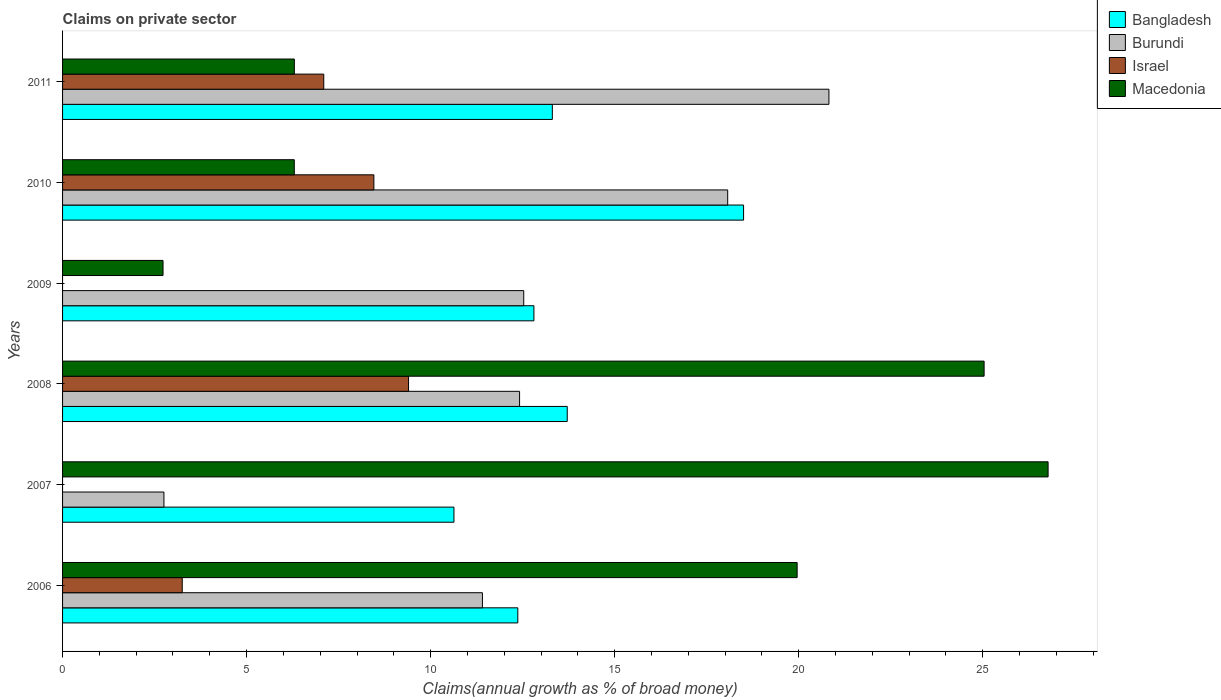Are the number of bars on each tick of the Y-axis equal?
Make the answer very short. No. How many bars are there on the 5th tick from the bottom?
Keep it short and to the point. 4. What is the percentage of broad money claimed on private sector in Bangladesh in 2006?
Give a very brief answer. 12.37. Across all years, what is the maximum percentage of broad money claimed on private sector in Bangladesh?
Provide a succinct answer. 18.5. Across all years, what is the minimum percentage of broad money claimed on private sector in Burundi?
Ensure brevity in your answer.  2.75. What is the total percentage of broad money claimed on private sector in Israel in the graph?
Offer a very short reply. 28.21. What is the difference between the percentage of broad money claimed on private sector in Israel in 2008 and that in 2011?
Your answer should be compact. 2.3. What is the difference between the percentage of broad money claimed on private sector in Bangladesh in 2006 and the percentage of broad money claimed on private sector in Macedonia in 2009?
Keep it short and to the point. 9.64. What is the average percentage of broad money claimed on private sector in Bangladesh per year?
Keep it short and to the point. 13.56. In the year 2007, what is the difference between the percentage of broad money claimed on private sector in Macedonia and percentage of broad money claimed on private sector in Bangladesh?
Offer a very short reply. 16.14. In how many years, is the percentage of broad money claimed on private sector in Burundi greater than 13 %?
Ensure brevity in your answer.  2. What is the ratio of the percentage of broad money claimed on private sector in Macedonia in 2007 to that in 2011?
Ensure brevity in your answer.  4.25. Is the percentage of broad money claimed on private sector in Macedonia in 2006 less than that in 2007?
Offer a very short reply. Yes. What is the difference between the highest and the second highest percentage of broad money claimed on private sector in Israel?
Ensure brevity in your answer.  0.94. What is the difference between the highest and the lowest percentage of broad money claimed on private sector in Bangladesh?
Ensure brevity in your answer.  7.87. Is it the case that in every year, the sum of the percentage of broad money claimed on private sector in Israel and percentage of broad money claimed on private sector in Macedonia is greater than the percentage of broad money claimed on private sector in Bangladesh?
Provide a short and direct response. No. How many bars are there?
Your response must be concise. 22. How many years are there in the graph?
Give a very brief answer. 6. Does the graph contain any zero values?
Your answer should be very brief. Yes. How many legend labels are there?
Your response must be concise. 4. How are the legend labels stacked?
Make the answer very short. Vertical. What is the title of the graph?
Your answer should be very brief. Claims on private sector. Does "Kazakhstan" appear as one of the legend labels in the graph?
Your answer should be very brief. No. What is the label or title of the X-axis?
Your response must be concise. Claims(annual growth as % of broad money). What is the label or title of the Y-axis?
Provide a short and direct response. Years. What is the Claims(annual growth as % of broad money) in Bangladesh in 2006?
Give a very brief answer. 12.37. What is the Claims(annual growth as % of broad money) in Burundi in 2006?
Your response must be concise. 11.41. What is the Claims(annual growth as % of broad money) in Israel in 2006?
Keep it short and to the point. 3.25. What is the Claims(annual growth as % of broad money) in Macedonia in 2006?
Your response must be concise. 19.96. What is the Claims(annual growth as % of broad money) in Bangladesh in 2007?
Offer a very short reply. 10.63. What is the Claims(annual growth as % of broad money) in Burundi in 2007?
Your answer should be very brief. 2.75. What is the Claims(annual growth as % of broad money) in Macedonia in 2007?
Offer a very short reply. 26.78. What is the Claims(annual growth as % of broad money) of Bangladesh in 2008?
Your response must be concise. 13.71. What is the Claims(annual growth as % of broad money) in Burundi in 2008?
Your answer should be compact. 12.42. What is the Claims(annual growth as % of broad money) of Israel in 2008?
Provide a succinct answer. 9.4. What is the Claims(annual growth as % of broad money) in Macedonia in 2008?
Offer a very short reply. 25.04. What is the Claims(annual growth as % of broad money) of Bangladesh in 2009?
Your answer should be compact. 12.81. What is the Claims(annual growth as % of broad money) in Burundi in 2009?
Make the answer very short. 12.53. What is the Claims(annual growth as % of broad money) of Israel in 2009?
Keep it short and to the point. 0. What is the Claims(annual growth as % of broad money) in Macedonia in 2009?
Give a very brief answer. 2.73. What is the Claims(annual growth as % of broad money) in Bangladesh in 2010?
Ensure brevity in your answer.  18.5. What is the Claims(annual growth as % of broad money) of Burundi in 2010?
Your answer should be compact. 18.07. What is the Claims(annual growth as % of broad money) in Israel in 2010?
Your answer should be compact. 8.46. What is the Claims(annual growth as % of broad money) of Macedonia in 2010?
Your response must be concise. 6.3. What is the Claims(annual growth as % of broad money) in Bangladesh in 2011?
Give a very brief answer. 13.31. What is the Claims(annual growth as % of broad money) of Burundi in 2011?
Provide a short and direct response. 20.82. What is the Claims(annual growth as % of broad money) of Israel in 2011?
Provide a short and direct response. 7.1. What is the Claims(annual growth as % of broad money) of Macedonia in 2011?
Your response must be concise. 6.3. Across all years, what is the maximum Claims(annual growth as % of broad money) in Bangladesh?
Make the answer very short. 18.5. Across all years, what is the maximum Claims(annual growth as % of broad money) in Burundi?
Your answer should be very brief. 20.82. Across all years, what is the maximum Claims(annual growth as % of broad money) in Israel?
Make the answer very short. 9.4. Across all years, what is the maximum Claims(annual growth as % of broad money) in Macedonia?
Provide a succinct answer. 26.78. Across all years, what is the minimum Claims(annual growth as % of broad money) of Bangladesh?
Ensure brevity in your answer.  10.63. Across all years, what is the minimum Claims(annual growth as % of broad money) of Burundi?
Your answer should be compact. 2.75. Across all years, what is the minimum Claims(annual growth as % of broad money) of Macedonia?
Offer a terse response. 2.73. What is the total Claims(annual growth as % of broad money) of Bangladesh in the graph?
Keep it short and to the point. 81.34. What is the total Claims(annual growth as % of broad money) of Burundi in the graph?
Offer a terse response. 78.01. What is the total Claims(annual growth as % of broad money) in Israel in the graph?
Your response must be concise. 28.21. What is the total Claims(annual growth as % of broad money) of Macedonia in the graph?
Your response must be concise. 87.1. What is the difference between the Claims(annual growth as % of broad money) in Bangladesh in 2006 and that in 2007?
Offer a terse response. 1.74. What is the difference between the Claims(annual growth as % of broad money) of Burundi in 2006 and that in 2007?
Offer a very short reply. 8.65. What is the difference between the Claims(annual growth as % of broad money) in Macedonia in 2006 and that in 2007?
Provide a short and direct response. -6.82. What is the difference between the Claims(annual growth as % of broad money) of Bangladesh in 2006 and that in 2008?
Give a very brief answer. -1.34. What is the difference between the Claims(annual growth as % of broad money) in Burundi in 2006 and that in 2008?
Your answer should be very brief. -1.01. What is the difference between the Claims(annual growth as % of broad money) in Israel in 2006 and that in 2008?
Offer a terse response. -6.15. What is the difference between the Claims(annual growth as % of broad money) of Macedonia in 2006 and that in 2008?
Your response must be concise. -5.08. What is the difference between the Claims(annual growth as % of broad money) of Bangladesh in 2006 and that in 2009?
Your answer should be very brief. -0.44. What is the difference between the Claims(annual growth as % of broad money) in Burundi in 2006 and that in 2009?
Provide a short and direct response. -1.12. What is the difference between the Claims(annual growth as % of broad money) in Macedonia in 2006 and that in 2009?
Ensure brevity in your answer.  17.23. What is the difference between the Claims(annual growth as % of broad money) of Bangladesh in 2006 and that in 2010?
Keep it short and to the point. -6.13. What is the difference between the Claims(annual growth as % of broad money) of Burundi in 2006 and that in 2010?
Offer a terse response. -6.66. What is the difference between the Claims(annual growth as % of broad money) in Israel in 2006 and that in 2010?
Offer a terse response. -5.21. What is the difference between the Claims(annual growth as % of broad money) of Macedonia in 2006 and that in 2010?
Offer a terse response. 13.66. What is the difference between the Claims(annual growth as % of broad money) in Bangladesh in 2006 and that in 2011?
Offer a terse response. -0.94. What is the difference between the Claims(annual growth as % of broad money) in Burundi in 2006 and that in 2011?
Ensure brevity in your answer.  -9.41. What is the difference between the Claims(annual growth as % of broad money) of Israel in 2006 and that in 2011?
Provide a short and direct response. -3.85. What is the difference between the Claims(annual growth as % of broad money) of Macedonia in 2006 and that in 2011?
Provide a succinct answer. 13.66. What is the difference between the Claims(annual growth as % of broad money) in Bangladesh in 2007 and that in 2008?
Your answer should be very brief. -3.08. What is the difference between the Claims(annual growth as % of broad money) of Burundi in 2007 and that in 2008?
Your response must be concise. -9.66. What is the difference between the Claims(annual growth as % of broad money) of Macedonia in 2007 and that in 2008?
Give a very brief answer. 1.74. What is the difference between the Claims(annual growth as % of broad money) in Bangladesh in 2007 and that in 2009?
Your response must be concise. -2.17. What is the difference between the Claims(annual growth as % of broad money) of Burundi in 2007 and that in 2009?
Give a very brief answer. -9.78. What is the difference between the Claims(annual growth as % of broad money) of Macedonia in 2007 and that in 2009?
Your response must be concise. 24.05. What is the difference between the Claims(annual growth as % of broad money) in Bangladesh in 2007 and that in 2010?
Offer a very short reply. -7.87. What is the difference between the Claims(annual growth as % of broad money) in Burundi in 2007 and that in 2010?
Provide a short and direct response. -15.32. What is the difference between the Claims(annual growth as % of broad money) of Macedonia in 2007 and that in 2010?
Provide a succinct answer. 20.48. What is the difference between the Claims(annual growth as % of broad money) in Bangladesh in 2007 and that in 2011?
Ensure brevity in your answer.  -2.67. What is the difference between the Claims(annual growth as % of broad money) in Burundi in 2007 and that in 2011?
Offer a very short reply. -18.07. What is the difference between the Claims(annual growth as % of broad money) in Macedonia in 2007 and that in 2011?
Your answer should be compact. 20.48. What is the difference between the Claims(annual growth as % of broad money) of Bangladesh in 2008 and that in 2009?
Your response must be concise. 0.91. What is the difference between the Claims(annual growth as % of broad money) in Burundi in 2008 and that in 2009?
Provide a short and direct response. -0.11. What is the difference between the Claims(annual growth as % of broad money) in Macedonia in 2008 and that in 2009?
Keep it short and to the point. 22.31. What is the difference between the Claims(annual growth as % of broad money) in Bangladesh in 2008 and that in 2010?
Offer a terse response. -4.79. What is the difference between the Claims(annual growth as % of broad money) in Burundi in 2008 and that in 2010?
Provide a succinct answer. -5.65. What is the difference between the Claims(annual growth as % of broad money) of Israel in 2008 and that in 2010?
Your response must be concise. 0.94. What is the difference between the Claims(annual growth as % of broad money) in Macedonia in 2008 and that in 2010?
Your answer should be very brief. 18.74. What is the difference between the Claims(annual growth as % of broad money) of Bangladesh in 2008 and that in 2011?
Provide a short and direct response. 0.41. What is the difference between the Claims(annual growth as % of broad money) in Burundi in 2008 and that in 2011?
Keep it short and to the point. -8.41. What is the difference between the Claims(annual growth as % of broad money) in Israel in 2008 and that in 2011?
Your response must be concise. 2.3. What is the difference between the Claims(annual growth as % of broad money) in Macedonia in 2008 and that in 2011?
Your answer should be compact. 18.74. What is the difference between the Claims(annual growth as % of broad money) of Bangladesh in 2009 and that in 2010?
Make the answer very short. -5.7. What is the difference between the Claims(annual growth as % of broad money) of Burundi in 2009 and that in 2010?
Make the answer very short. -5.54. What is the difference between the Claims(annual growth as % of broad money) of Macedonia in 2009 and that in 2010?
Offer a terse response. -3.57. What is the difference between the Claims(annual growth as % of broad money) in Bangladesh in 2009 and that in 2011?
Your answer should be very brief. -0.5. What is the difference between the Claims(annual growth as % of broad money) in Burundi in 2009 and that in 2011?
Provide a succinct answer. -8.29. What is the difference between the Claims(annual growth as % of broad money) of Macedonia in 2009 and that in 2011?
Your answer should be compact. -3.57. What is the difference between the Claims(annual growth as % of broad money) of Bangladesh in 2010 and that in 2011?
Ensure brevity in your answer.  5.2. What is the difference between the Claims(annual growth as % of broad money) in Burundi in 2010 and that in 2011?
Make the answer very short. -2.75. What is the difference between the Claims(annual growth as % of broad money) in Israel in 2010 and that in 2011?
Provide a short and direct response. 1.36. What is the difference between the Claims(annual growth as % of broad money) of Macedonia in 2010 and that in 2011?
Your answer should be compact. -0. What is the difference between the Claims(annual growth as % of broad money) in Bangladesh in 2006 and the Claims(annual growth as % of broad money) in Burundi in 2007?
Make the answer very short. 9.62. What is the difference between the Claims(annual growth as % of broad money) in Bangladesh in 2006 and the Claims(annual growth as % of broad money) in Macedonia in 2007?
Ensure brevity in your answer.  -14.41. What is the difference between the Claims(annual growth as % of broad money) of Burundi in 2006 and the Claims(annual growth as % of broad money) of Macedonia in 2007?
Your answer should be compact. -15.37. What is the difference between the Claims(annual growth as % of broad money) of Israel in 2006 and the Claims(annual growth as % of broad money) of Macedonia in 2007?
Offer a very short reply. -23.53. What is the difference between the Claims(annual growth as % of broad money) of Bangladesh in 2006 and the Claims(annual growth as % of broad money) of Burundi in 2008?
Provide a succinct answer. -0.05. What is the difference between the Claims(annual growth as % of broad money) of Bangladesh in 2006 and the Claims(annual growth as % of broad money) of Israel in 2008?
Ensure brevity in your answer.  2.97. What is the difference between the Claims(annual growth as % of broad money) of Bangladesh in 2006 and the Claims(annual growth as % of broad money) of Macedonia in 2008?
Your answer should be very brief. -12.67. What is the difference between the Claims(annual growth as % of broad money) in Burundi in 2006 and the Claims(annual growth as % of broad money) in Israel in 2008?
Your answer should be very brief. 2.01. What is the difference between the Claims(annual growth as % of broad money) in Burundi in 2006 and the Claims(annual growth as % of broad money) in Macedonia in 2008?
Offer a terse response. -13.63. What is the difference between the Claims(annual growth as % of broad money) in Israel in 2006 and the Claims(annual growth as % of broad money) in Macedonia in 2008?
Give a very brief answer. -21.79. What is the difference between the Claims(annual growth as % of broad money) of Bangladesh in 2006 and the Claims(annual growth as % of broad money) of Burundi in 2009?
Offer a terse response. -0.16. What is the difference between the Claims(annual growth as % of broad money) of Bangladesh in 2006 and the Claims(annual growth as % of broad money) of Macedonia in 2009?
Your answer should be very brief. 9.64. What is the difference between the Claims(annual growth as % of broad money) in Burundi in 2006 and the Claims(annual growth as % of broad money) in Macedonia in 2009?
Make the answer very short. 8.68. What is the difference between the Claims(annual growth as % of broad money) in Israel in 2006 and the Claims(annual growth as % of broad money) in Macedonia in 2009?
Offer a terse response. 0.52. What is the difference between the Claims(annual growth as % of broad money) in Bangladesh in 2006 and the Claims(annual growth as % of broad money) in Burundi in 2010?
Provide a short and direct response. -5.7. What is the difference between the Claims(annual growth as % of broad money) of Bangladesh in 2006 and the Claims(annual growth as % of broad money) of Israel in 2010?
Offer a terse response. 3.91. What is the difference between the Claims(annual growth as % of broad money) of Bangladesh in 2006 and the Claims(annual growth as % of broad money) of Macedonia in 2010?
Offer a very short reply. 6.07. What is the difference between the Claims(annual growth as % of broad money) of Burundi in 2006 and the Claims(annual growth as % of broad money) of Israel in 2010?
Your answer should be compact. 2.95. What is the difference between the Claims(annual growth as % of broad money) in Burundi in 2006 and the Claims(annual growth as % of broad money) in Macedonia in 2010?
Make the answer very short. 5.11. What is the difference between the Claims(annual growth as % of broad money) in Israel in 2006 and the Claims(annual growth as % of broad money) in Macedonia in 2010?
Your response must be concise. -3.04. What is the difference between the Claims(annual growth as % of broad money) in Bangladesh in 2006 and the Claims(annual growth as % of broad money) in Burundi in 2011?
Offer a terse response. -8.45. What is the difference between the Claims(annual growth as % of broad money) in Bangladesh in 2006 and the Claims(annual growth as % of broad money) in Israel in 2011?
Make the answer very short. 5.27. What is the difference between the Claims(annual growth as % of broad money) of Bangladesh in 2006 and the Claims(annual growth as % of broad money) of Macedonia in 2011?
Provide a short and direct response. 6.07. What is the difference between the Claims(annual growth as % of broad money) of Burundi in 2006 and the Claims(annual growth as % of broad money) of Israel in 2011?
Offer a terse response. 4.31. What is the difference between the Claims(annual growth as % of broad money) of Burundi in 2006 and the Claims(annual growth as % of broad money) of Macedonia in 2011?
Keep it short and to the point. 5.11. What is the difference between the Claims(annual growth as % of broad money) of Israel in 2006 and the Claims(annual growth as % of broad money) of Macedonia in 2011?
Your answer should be compact. -3.05. What is the difference between the Claims(annual growth as % of broad money) in Bangladesh in 2007 and the Claims(annual growth as % of broad money) in Burundi in 2008?
Provide a short and direct response. -1.78. What is the difference between the Claims(annual growth as % of broad money) in Bangladesh in 2007 and the Claims(annual growth as % of broad money) in Israel in 2008?
Your answer should be very brief. 1.23. What is the difference between the Claims(annual growth as % of broad money) of Bangladesh in 2007 and the Claims(annual growth as % of broad money) of Macedonia in 2008?
Your answer should be compact. -14.4. What is the difference between the Claims(annual growth as % of broad money) of Burundi in 2007 and the Claims(annual growth as % of broad money) of Israel in 2008?
Offer a terse response. -6.65. What is the difference between the Claims(annual growth as % of broad money) of Burundi in 2007 and the Claims(annual growth as % of broad money) of Macedonia in 2008?
Offer a terse response. -22.28. What is the difference between the Claims(annual growth as % of broad money) of Bangladesh in 2007 and the Claims(annual growth as % of broad money) of Burundi in 2009?
Keep it short and to the point. -1.9. What is the difference between the Claims(annual growth as % of broad money) of Bangladesh in 2007 and the Claims(annual growth as % of broad money) of Macedonia in 2009?
Offer a terse response. 7.9. What is the difference between the Claims(annual growth as % of broad money) of Burundi in 2007 and the Claims(annual growth as % of broad money) of Macedonia in 2009?
Provide a short and direct response. 0.02. What is the difference between the Claims(annual growth as % of broad money) of Bangladesh in 2007 and the Claims(annual growth as % of broad money) of Burundi in 2010?
Your response must be concise. -7.44. What is the difference between the Claims(annual growth as % of broad money) in Bangladesh in 2007 and the Claims(annual growth as % of broad money) in Israel in 2010?
Provide a succinct answer. 2.18. What is the difference between the Claims(annual growth as % of broad money) in Bangladesh in 2007 and the Claims(annual growth as % of broad money) in Macedonia in 2010?
Offer a terse response. 4.34. What is the difference between the Claims(annual growth as % of broad money) in Burundi in 2007 and the Claims(annual growth as % of broad money) in Israel in 2010?
Ensure brevity in your answer.  -5.7. What is the difference between the Claims(annual growth as % of broad money) of Burundi in 2007 and the Claims(annual growth as % of broad money) of Macedonia in 2010?
Your response must be concise. -3.54. What is the difference between the Claims(annual growth as % of broad money) of Bangladesh in 2007 and the Claims(annual growth as % of broad money) of Burundi in 2011?
Give a very brief answer. -10.19. What is the difference between the Claims(annual growth as % of broad money) in Bangladesh in 2007 and the Claims(annual growth as % of broad money) in Israel in 2011?
Your answer should be compact. 3.54. What is the difference between the Claims(annual growth as % of broad money) of Bangladesh in 2007 and the Claims(annual growth as % of broad money) of Macedonia in 2011?
Provide a short and direct response. 4.34. What is the difference between the Claims(annual growth as % of broad money) of Burundi in 2007 and the Claims(annual growth as % of broad money) of Israel in 2011?
Ensure brevity in your answer.  -4.34. What is the difference between the Claims(annual growth as % of broad money) in Burundi in 2007 and the Claims(annual growth as % of broad money) in Macedonia in 2011?
Provide a succinct answer. -3.54. What is the difference between the Claims(annual growth as % of broad money) of Bangladesh in 2008 and the Claims(annual growth as % of broad money) of Burundi in 2009?
Make the answer very short. 1.18. What is the difference between the Claims(annual growth as % of broad money) of Bangladesh in 2008 and the Claims(annual growth as % of broad money) of Macedonia in 2009?
Make the answer very short. 10.98. What is the difference between the Claims(annual growth as % of broad money) in Burundi in 2008 and the Claims(annual growth as % of broad money) in Macedonia in 2009?
Make the answer very short. 9.69. What is the difference between the Claims(annual growth as % of broad money) of Israel in 2008 and the Claims(annual growth as % of broad money) of Macedonia in 2009?
Keep it short and to the point. 6.67. What is the difference between the Claims(annual growth as % of broad money) of Bangladesh in 2008 and the Claims(annual growth as % of broad money) of Burundi in 2010?
Ensure brevity in your answer.  -4.36. What is the difference between the Claims(annual growth as % of broad money) of Bangladesh in 2008 and the Claims(annual growth as % of broad money) of Israel in 2010?
Offer a terse response. 5.25. What is the difference between the Claims(annual growth as % of broad money) of Bangladesh in 2008 and the Claims(annual growth as % of broad money) of Macedonia in 2010?
Provide a succinct answer. 7.42. What is the difference between the Claims(annual growth as % of broad money) of Burundi in 2008 and the Claims(annual growth as % of broad money) of Israel in 2010?
Offer a very short reply. 3.96. What is the difference between the Claims(annual growth as % of broad money) in Burundi in 2008 and the Claims(annual growth as % of broad money) in Macedonia in 2010?
Your answer should be very brief. 6.12. What is the difference between the Claims(annual growth as % of broad money) of Israel in 2008 and the Claims(annual growth as % of broad money) of Macedonia in 2010?
Give a very brief answer. 3.1. What is the difference between the Claims(annual growth as % of broad money) of Bangladesh in 2008 and the Claims(annual growth as % of broad money) of Burundi in 2011?
Your answer should be compact. -7.11. What is the difference between the Claims(annual growth as % of broad money) in Bangladesh in 2008 and the Claims(annual growth as % of broad money) in Israel in 2011?
Your answer should be compact. 6.62. What is the difference between the Claims(annual growth as % of broad money) in Bangladesh in 2008 and the Claims(annual growth as % of broad money) in Macedonia in 2011?
Ensure brevity in your answer.  7.42. What is the difference between the Claims(annual growth as % of broad money) in Burundi in 2008 and the Claims(annual growth as % of broad money) in Israel in 2011?
Your answer should be compact. 5.32. What is the difference between the Claims(annual growth as % of broad money) in Burundi in 2008 and the Claims(annual growth as % of broad money) in Macedonia in 2011?
Make the answer very short. 6.12. What is the difference between the Claims(annual growth as % of broad money) in Israel in 2008 and the Claims(annual growth as % of broad money) in Macedonia in 2011?
Offer a terse response. 3.1. What is the difference between the Claims(annual growth as % of broad money) in Bangladesh in 2009 and the Claims(annual growth as % of broad money) in Burundi in 2010?
Your answer should be very brief. -5.26. What is the difference between the Claims(annual growth as % of broad money) in Bangladesh in 2009 and the Claims(annual growth as % of broad money) in Israel in 2010?
Keep it short and to the point. 4.35. What is the difference between the Claims(annual growth as % of broad money) in Bangladesh in 2009 and the Claims(annual growth as % of broad money) in Macedonia in 2010?
Offer a very short reply. 6.51. What is the difference between the Claims(annual growth as % of broad money) in Burundi in 2009 and the Claims(annual growth as % of broad money) in Israel in 2010?
Your answer should be compact. 4.07. What is the difference between the Claims(annual growth as % of broad money) in Burundi in 2009 and the Claims(annual growth as % of broad money) in Macedonia in 2010?
Provide a succinct answer. 6.23. What is the difference between the Claims(annual growth as % of broad money) of Bangladesh in 2009 and the Claims(annual growth as % of broad money) of Burundi in 2011?
Offer a terse response. -8.02. What is the difference between the Claims(annual growth as % of broad money) of Bangladesh in 2009 and the Claims(annual growth as % of broad money) of Israel in 2011?
Give a very brief answer. 5.71. What is the difference between the Claims(annual growth as % of broad money) of Bangladesh in 2009 and the Claims(annual growth as % of broad money) of Macedonia in 2011?
Offer a very short reply. 6.51. What is the difference between the Claims(annual growth as % of broad money) in Burundi in 2009 and the Claims(annual growth as % of broad money) in Israel in 2011?
Your answer should be very brief. 5.43. What is the difference between the Claims(annual growth as % of broad money) in Burundi in 2009 and the Claims(annual growth as % of broad money) in Macedonia in 2011?
Offer a terse response. 6.23. What is the difference between the Claims(annual growth as % of broad money) in Bangladesh in 2010 and the Claims(annual growth as % of broad money) in Burundi in 2011?
Offer a terse response. -2.32. What is the difference between the Claims(annual growth as % of broad money) in Bangladesh in 2010 and the Claims(annual growth as % of broad money) in Israel in 2011?
Keep it short and to the point. 11.41. What is the difference between the Claims(annual growth as % of broad money) of Bangladesh in 2010 and the Claims(annual growth as % of broad money) of Macedonia in 2011?
Provide a short and direct response. 12.21. What is the difference between the Claims(annual growth as % of broad money) in Burundi in 2010 and the Claims(annual growth as % of broad money) in Israel in 2011?
Make the answer very short. 10.97. What is the difference between the Claims(annual growth as % of broad money) in Burundi in 2010 and the Claims(annual growth as % of broad money) in Macedonia in 2011?
Ensure brevity in your answer.  11.77. What is the difference between the Claims(annual growth as % of broad money) in Israel in 2010 and the Claims(annual growth as % of broad money) in Macedonia in 2011?
Your response must be concise. 2.16. What is the average Claims(annual growth as % of broad money) of Bangladesh per year?
Keep it short and to the point. 13.56. What is the average Claims(annual growth as % of broad money) of Burundi per year?
Make the answer very short. 13. What is the average Claims(annual growth as % of broad money) in Israel per year?
Your answer should be very brief. 4.7. What is the average Claims(annual growth as % of broad money) of Macedonia per year?
Provide a succinct answer. 14.52. In the year 2006, what is the difference between the Claims(annual growth as % of broad money) of Bangladesh and Claims(annual growth as % of broad money) of Burundi?
Ensure brevity in your answer.  0.96. In the year 2006, what is the difference between the Claims(annual growth as % of broad money) in Bangladesh and Claims(annual growth as % of broad money) in Israel?
Ensure brevity in your answer.  9.12. In the year 2006, what is the difference between the Claims(annual growth as % of broad money) in Bangladesh and Claims(annual growth as % of broad money) in Macedonia?
Provide a succinct answer. -7.59. In the year 2006, what is the difference between the Claims(annual growth as % of broad money) of Burundi and Claims(annual growth as % of broad money) of Israel?
Ensure brevity in your answer.  8.16. In the year 2006, what is the difference between the Claims(annual growth as % of broad money) of Burundi and Claims(annual growth as % of broad money) of Macedonia?
Keep it short and to the point. -8.55. In the year 2006, what is the difference between the Claims(annual growth as % of broad money) of Israel and Claims(annual growth as % of broad money) of Macedonia?
Your response must be concise. -16.71. In the year 2007, what is the difference between the Claims(annual growth as % of broad money) of Bangladesh and Claims(annual growth as % of broad money) of Burundi?
Ensure brevity in your answer.  7.88. In the year 2007, what is the difference between the Claims(annual growth as % of broad money) in Bangladesh and Claims(annual growth as % of broad money) in Macedonia?
Ensure brevity in your answer.  -16.14. In the year 2007, what is the difference between the Claims(annual growth as % of broad money) of Burundi and Claims(annual growth as % of broad money) of Macedonia?
Provide a short and direct response. -24.02. In the year 2008, what is the difference between the Claims(annual growth as % of broad money) in Bangladesh and Claims(annual growth as % of broad money) in Burundi?
Keep it short and to the point. 1.3. In the year 2008, what is the difference between the Claims(annual growth as % of broad money) of Bangladesh and Claims(annual growth as % of broad money) of Israel?
Provide a succinct answer. 4.31. In the year 2008, what is the difference between the Claims(annual growth as % of broad money) in Bangladesh and Claims(annual growth as % of broad money) in Macedonia?
Provide a short and direct response. -11.33. In the year 2008, what is the difference between the Claims(annual growth as % of broad money) of Burundi and Claims(annual growth as % of broad money) of Israel?
Ensure brevity in your answer.  3.02. In the year 2008, what is the difference between the Claims(annual growth as % of broad money) in Burundi and Claims(annual growth as % of broad money) in Macedonia?
Give a very brief answer. -12.62. In the year 2008, what is the difference between the Claims(annual growth as % of broad money) of Israel and Claims(annual growth as % of broad money) of Macedonia?
Your answer should be compact. -15.64. In the year 2009, what is the difference between the Claims(annual growth as % of broad money) of Bangladesh and Claims(annual growth as % of broad money) of Burundi?
Provide a short and direct response. 0.28. In the year 2009, what is the difference between the Claims(annual growth as % of broad money) in Bangladesh and Claims(annual growth as % of broad money) in Macedonia?
Your answer should be compact. 10.08. In the year 2009, what is the difference between the Claims(annual growth as % of broad money) in Burundi and Claims(annual growth as % of broad money) in Macedonia?
Give a very brief answer. 9.8. In the year 2010, what is the difference between the Claims(annual growth as % of broad money) in Bangladesh and Claims(annual growth as % of broad money) in Burundi?
Keep it short and to the point. 0.43. In the year 2010, what is the difference between the Claims(annual growth as % of broad money) in Bangladesh and Claims(annual growth as % of broad money) in Israel?
Keep it short and to the point. 10.05. In the year 2010, what is the difference between the Claims(annual growth as % of broad money) in Bangladesh and Claims(annual growth as % of broad money) in Macedonia?
Offer a very short reply. 12.21. In the year 2010, what is the difference between the Claims(annual growth as % of broad money) of Burundi and Claims(annual growth as % of broad money) of Israel?
Offer a terse response. 9.61. In the year 2010, what is the difference between the Claims(annual growth as % of broad money) in Burundi and Claims(annual growth as % of broad money) in Macedonia?
Give a very brief answer. 11.78. In the year 2010, what is the difference between the Claims(annual growth as % of broad money) of Israel and Claims(annual growth as % of broad money) of Macedonia?
Your response must be concise. 2.16. In the year 2011, what is the difference between the Claims(annual growth as % of broad money) of Bangladesh and Claims(annual growth as % of broad money) of Burundi?
Your response must be concise. -7.52. In the year 2011, what is the difference between the Claims(annual growth as % of broad money) in Bangladesh and Claims(annual growth as % of broad money) in Israel?
Ensure brevity in your answer.  6.21. In the year 2011, what is the difference between the Claims(annual growth as % of broad money) of Bangladesh and Claims(annual growth as % of broad money) of Macedonia?
Provide a short and direct response. 7.01. In the year 2011, what is the difference between the Claims(annual growth as % of broad money) of Burundi and Claims(annual growth as % of broad money) of Israel?
Offer a very short reply. 13.73. In the year 2011, what is the difference between the Claims(annual growth as % of broad money) of Burundi and Claims(annual growth as % of broad money) of Macedonia?
Your answer should be very brief. 14.53. In the year 2011, what is the difference between the Claims(annual growth as % of broad money) of Israel and Claims(annual growth as % of broad money) of Macedonia?
Provide a succinct answer. 0.8. What is the ratio of the Claims(annual growth as % of broad money) in Bangladesh in 2006 to that in 2007?
Your answer should be very brief. 1.16. What is the ratio of the Claims(annual growth as % of broad money) in Burundi in 2006 to that in 2007?
Offer a terse response. 4.14. What is the ratio of the Claims(annual growth as % of broad money) in Macedonia in 2006 to that in 2007?
Provide a succinct answer. 0.75. What is the ratio of the Claims(annual growth as % of broad money) in Bangladesh in 2006 to that in 2008?
Provide a short and direct response. 0.9. What is the ratio of the Claims(annual growth as % of broad money) of Burundi in 2006 to that in 2008?
Provide a short and direct response. 0.92. What is the ratio of the Claims(annual growth as % of broad money) in Israel in 2006 to that in 2008?
Provide a short and direct response. 0.35. What is the ratio of the Claims(annual growth as % of broad money) of Macedonia in 2006 to that in 2008?
Offer a very short reply. 0.8. What is the ratio of the Claims(annual growth as % of broad money) of Bangladesh in 2006 to that in 2009?
Your answer should be compact. 0.97. What is the ratio of the Claims(annual growth as % of broad money) in Burundi in 2006 to that in 2009?
Keep it short and to the point. 0.91. What is the ratio of the Claims(annual growth as % of broad money) in Macedonia in 2006 to that in 2009?
Your answer should be compact. 7.31. What is the ratio of the Claims(annual growth as % of broad money) of Bangladesh in 2006 to that in 2010?
Offer a very short reply. 0.67. What is the ratio of the Claims(annual growth as % of broad money) of Burundi in 2006 to that in 2010?
Offer a very short reply. 0.63. What is the ratio of the Claims(annual growth as % of broad money) of Israel in 2006 to that in 2010?
Offer a very short reply. 0.38. What is the ratio of the Claims(annual growth as % of broad money) of Macedonia in 2006 to that in 2010?
Your answer should be very brief. 3.17. What is the ratio of the Claims(annual growth as % of broad money) of Bangladesh in 2006 to that in 2011?
Keep it short and to the point. 0.93. What is the ratio of the Claims(annual growth as % of broad money) of Burundi in 2006 to that in 2011?
Your answer should be very brief. 0.55. What is the ratio of the Claims(annual growth as % of broad money) of Israel in 2006 to that in 2011?
Your response must be concise. 0.46. What is the ratio of the Claims(annual growth as % of broad money) of Macedonia in 2006 to that in 2011?
Ensure brevity in your answer.  3.17. What is the ratio of the Claims(annual growth as % of broad money) in Bangladesh in 2007 to that in 2008?
Your response must be concise. 0.78. What is the ratio of the Claims(annual growth as % of broad money) of Burundi in 2007 to that in 2008?
Provide a short and direct response. 0.22. What is the ratio of the Claims(annual growth as % of broad money) of Macedonia in 2007 to that in 2008?
Your answer should be compact. 1.07. What is the ratio of the Claims(annual growth as % of broad money) of Bangladesh in 2007 to that in 2009?
Your answer should be compact. 0.83. What is the ratio of the Claims(annual growth as % of broad money) of Burundi in 2007 to that in 2009?
Give a very brief answer. 0.22. What is the ratio of the Claims(annual growth as % of broad money) of Macedonia in 2007 to that in 2009?
Provide a short and direct response. 9.81. What is the ratio of the Claims(annual growth as % of broad money) in Bangladesh in 2007 to that in 2010?
Keep it short and to the point. 0.57. What is the ratio of the Claims(annual growth as % of broad money) in Burundi in 2007 to that in 2010?
Provide a short and direct response. 0.15. What is the ratio of the Claims(annual growth as % of broad money) in Macedonia in 2007 to that in 2010?
Keep it short and to the point. 4.25. What is the ratio of the Claims(annual growth as % of broad money) of Bangladesh in 2007 to that in 2011?
Your answer should be compact. 0.8. What is the ratio of the Claims(annual growth as % of broad money) of Burundi in 2007 to that in 2011?
Provide a succinct answer. 0.13. What is the ratio of the Claims(annual growth as % of broad money) in Macedonia in 2007 to that in 2011?
Your answer should be compact. 4.25. What is the ratio of the Claims(annual growth as % of broad money) of Bangladesh in 2008 to that in 2009?
Your answer should be compact. 1.07. What is the ratio of the Claims(annual growth as % of broad money) in Macedonia in 2008 to that in 2009?
Offer a terse response. 9.17. What is the ratio of the Claims(annual growth as % of broad money) of Bangladesh in 2008 to that in 2010?
Your answer should be very brief. 0.74. What is the ratio of the Claims(annual growth as % of broad money) in Burundi in 2008 to that in 2010?
Ensure brevity in your answer.  0.69. What is the ratio of the Claims(annual growth as % of broad money) of Israel in 2008 to that in 2010?
Your response must be concise. 1.11. What is the ratio of the Claims(annual growth as % of broad money) of Macedonia in 2008 to that in 2010?
Make the answer very short. 3.98. What is the ratio of the Claims(annual growth as % of broad money) in Bangladesh in 2008 to that in 2011?
Offer a terse response. 1.03. What is the ratio of the Claims(annual growth as % of broad money) in Burundi in 2008 to that in 2011?
Make the answer very short. 0.6. What is the ratio of the Claims(annual growth as % of broad money) of Israel in 2008 to that in 2011?
Give a very brief answer. 1.32. What is the ratio of the Claims(annual growth as % of broad money) in Macedonia in 2008 to that in 2011?
Your answer should be compact. 3.98. What is the ratio of the Claims(annual growth as % of broad money) of Bangladesh in 2009 to that in 2010?
Keep it short and to the point. 0.69. What is the ratio of the Claims(annual growth as % of broad money) in Burundi in 2009 to that in 2010?
Ensure brevity in your answer.  0.69. What is the ratio of the Claims(annual growth as % of broad money) of Macedonia in 2009 to that in 2010?
Offer a terse response. 0.43. What is the ratio of the Claims(annual growth as % of broad money) in Bangladesh in 2009 to that in 2011?
Keep it short and to the point. 0.96. What is the ratio of the Claims(annual growth as % of broad money) in Burundi in 2009 to that in 2011?
Keep it short and to the point. 0.6. What is the ratio of the Claims(annual growth as % of broad money) of Macedonia in 2009 to that in 2011?
Provide a succinct answer. 0.43. What is the ratio of the Claims(annual growth as % of broad money) of Bangladesh in 2010 to that in 2011?
Give a very brief answer. 1.39. What is the ratio of the Claims(annual growth as % of broad money) in Burundi in 2010 to that in 2011?
Give a very brief answer. 0.87. What is the ratio of the Claims(annual growth as % of broad money) of Israel in 2010 to that in 2011?
Offer a very short reply. 1.19. What is the difference between the highest and the second highest Claims(annual growth as % of broad money) in Bangladesh?
Provide a succinct answer. 4.79. What is the difference between the highest and the second highest Claims(annual growth as % of broad money) of Burundi?
Keep it short and to the point. 2.75. What is the difference between the highest and the second highest Claims(annual growth as % of broad money) of Israel?
Offer a very short reply. 0.94. What is the difference between the highest and the second highest Claims(annual growth as % of broad money) in Macedonia?
Your response must be concise. 1.74. What is the difference between the highest and the lowest Claims(annual growth as % of broad money) in Bangladesh?
Your response must be concise. 7.87. What is the difference between the highest and the lowest Claims(annual growth as % of broad money) in Burundi?
Your answer should be very brief. 18.07. What is the difference between the highest and the lowest Claims(annual growth as % of broad money) of Israel?
Give a very brief answer. 9.4. What is the difference between the highest and the lowest Claims(annual growth as % of broad money) of Macedonia?
Your response must be concise. 24.05. 